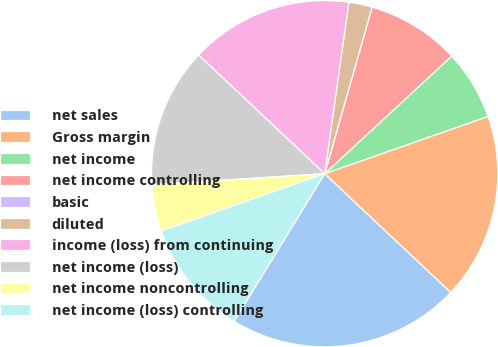Convert chart. <chart><loc_0><loc_0><loc_500><loc_500><pie_chart><fcel>net sales<fcel>Gross margin<fcel>net income<fcel>net income controlling<fcel>basic<fcel>diluted<fcel>income (loss) from continuing<fcel>net income (loss)<fcel>net income noncontrolling<fcel>net income (loss) controlling<nl><fcel>21.74%<fcel>17.39%<fcel>6.52%<fcel>8.7%<fcel>0.0%<fcel>2.18%<fcel>15.22%<fcel>13.04%<fcel>4.35%<fcel>10.87%<nl></chart> 